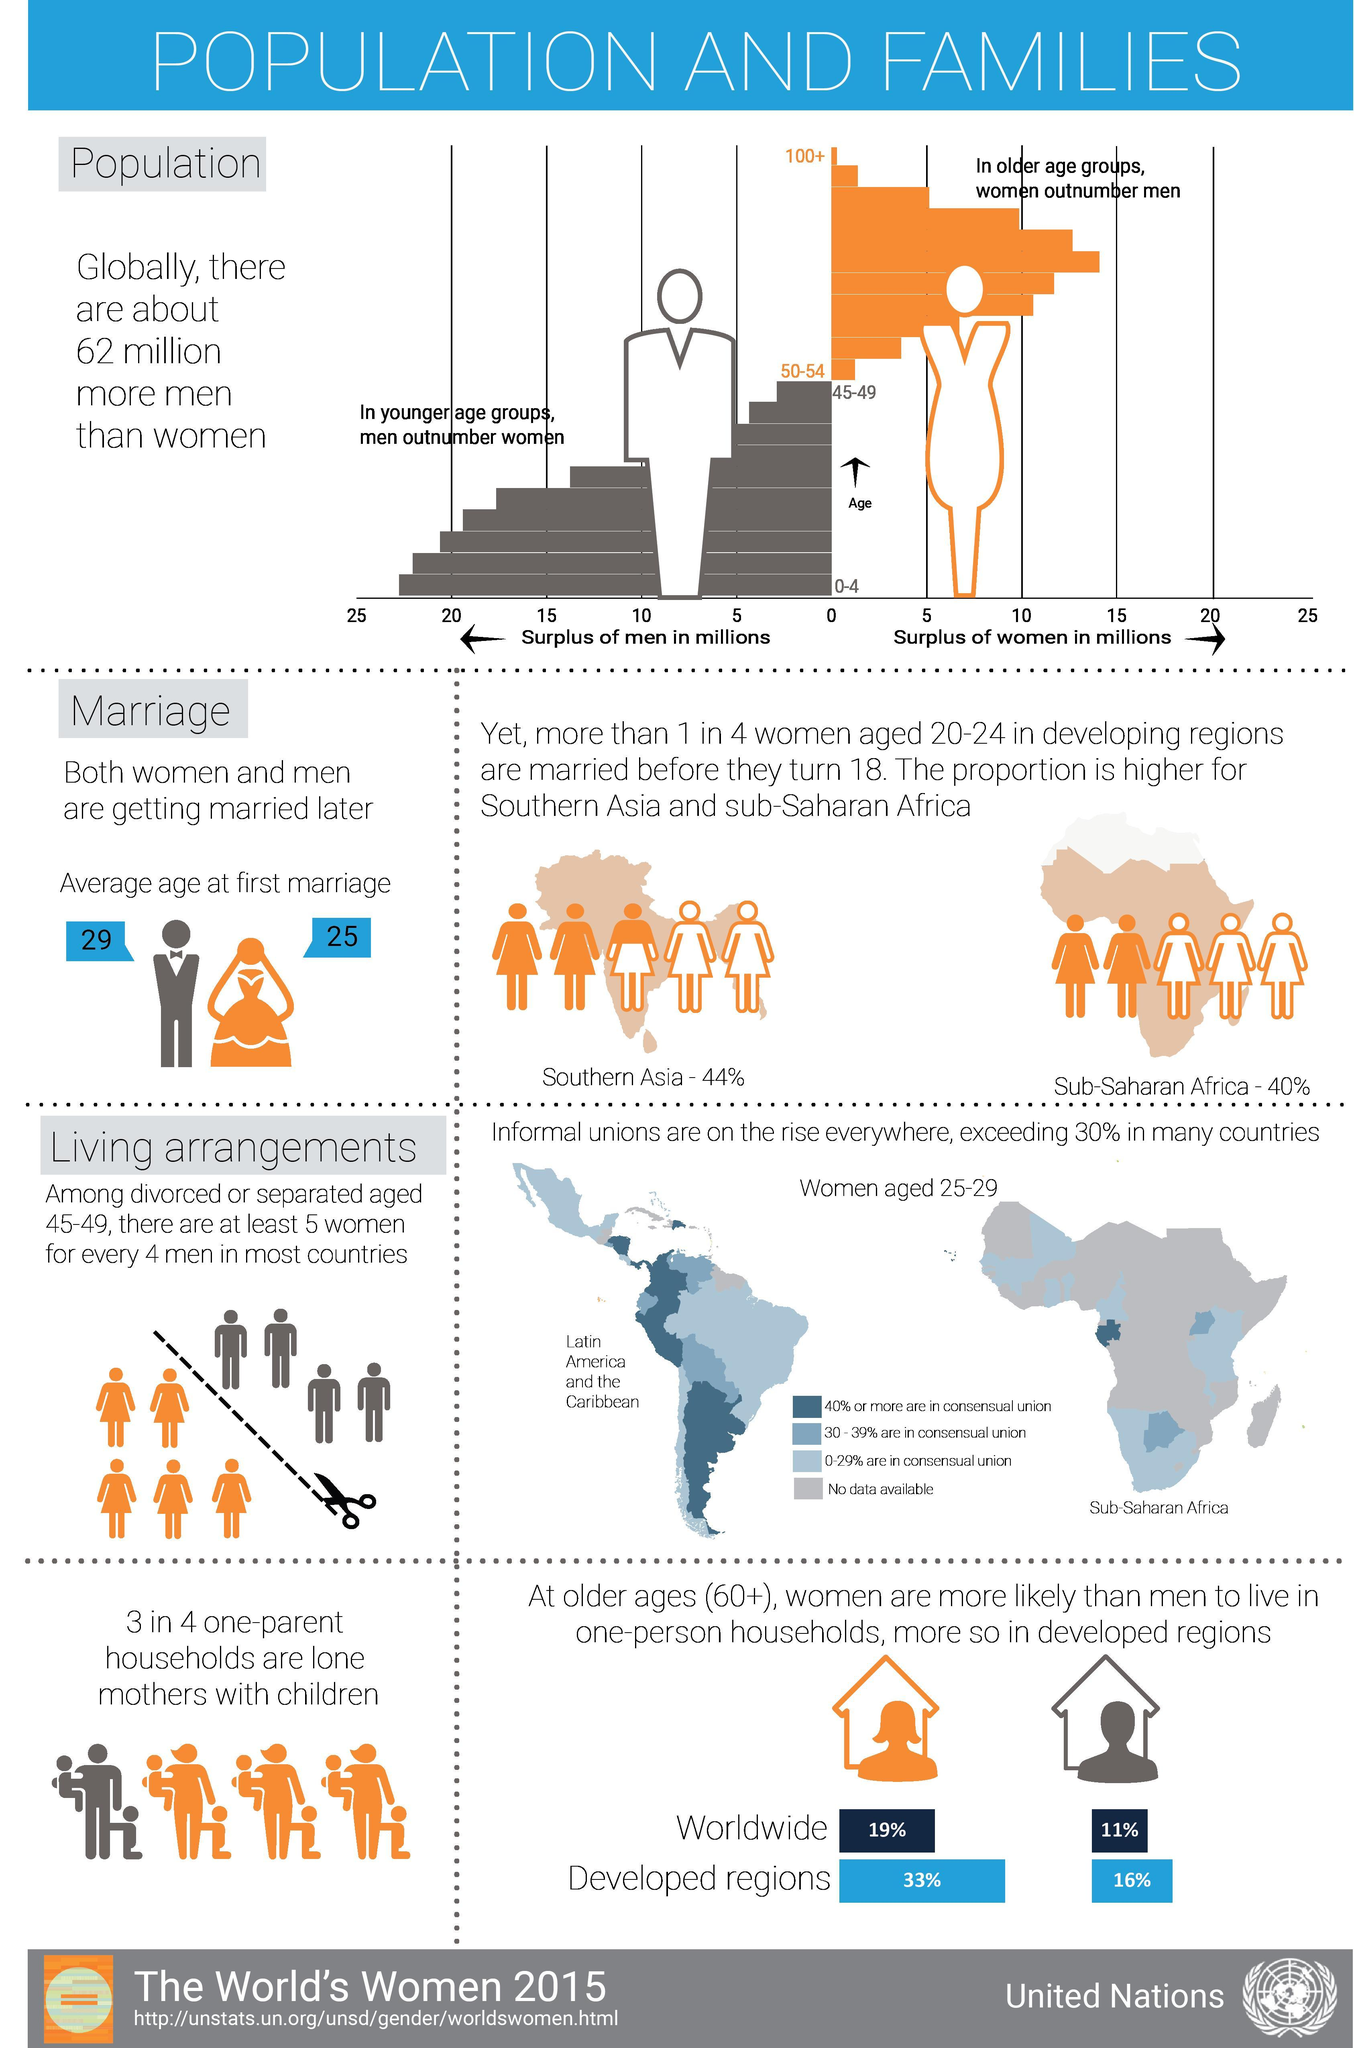What is the percentage of single mothers with children among one-parent households?
Answer the question with a short phrase. 75% How much more women aged 60+ are more likely to live in one-person households worldwide than men? 8% What color represents women in the graph, orange or red? orange What percentage of women aged 20-24 in developing regions are married before they turn 18? 25% What color represents men in the graph, orange or grey? grey How much more women aged 60+ are more likely to live in one-person households in developed regions than men? 17% 